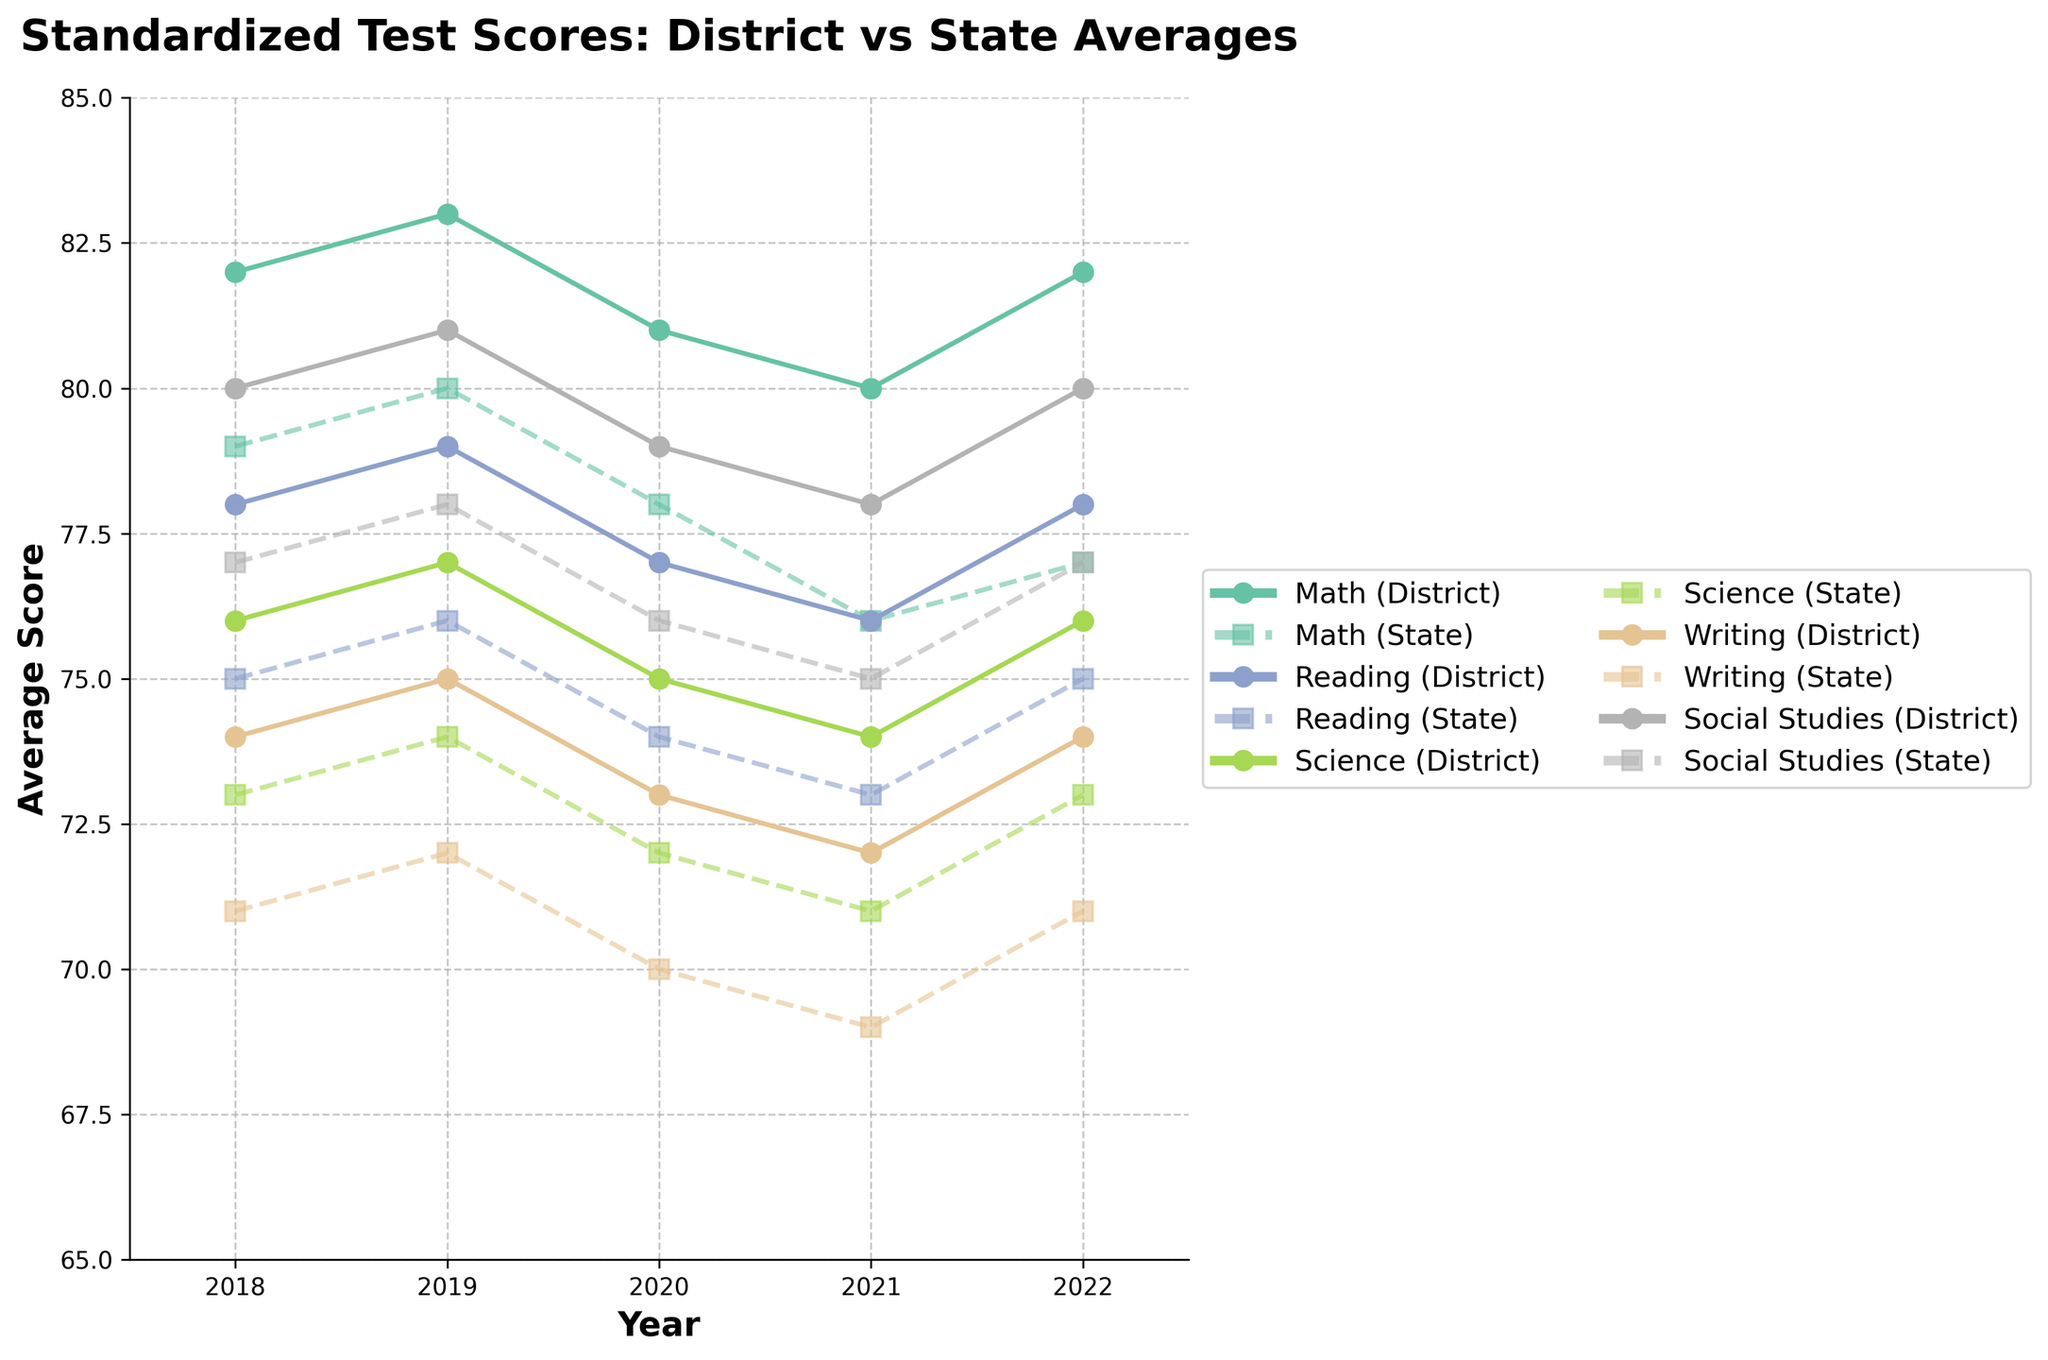What is the difference in Math scores between the district and the state in 2022? In the year 2022, the district average for Math is 82 while the state average is 77. The difference can be calculated by subtracting the state average from the district average: 82 - 77 = 5.
Answer: 5 Which subject shows the smallest difference between district and state averages in 2020? From the figure, observe the difference between district and state averages in 2020 for all subjects. The differences are: Math (81-78=3), Reading (77-74=3), Science (75-72=3), Writing (73-70=3), Social Studies (79-76=3). All subjects show the same smallest difference of 3 points.
Answer: All subjects During which year did the district average for Social Studies drop the most compared to the previous year? By examining the Social Studies district averages across the years: 2018 (80), 2019 (81), 2020 (79), 2021 (78), 2022 (80), the biggest drop occurred between 2019 and 2020, where the score dropped from 81 to 79, a drop of 2 points.
Answer: 2020 How does the trend in district average scores for Reading compare to the state average over the 5-year period? Over the 5-year period, the district and state average scores for Reading show a similar overall trend. Both see a slight decline from 2018 to 2021 and then an increase in 2022. Specifically, district scores go from 78 in 2018 to 78 in 2022, and state scores go from 75 in 2018 to 75 in 2022, reflecting stability in both.
Answer: Similar trend By how much did the district average for Writing change from 2018 to 2022? The Writing district average in 2018 was 74 and in 2022 it was 74 as well. The change from 2018 to 2022 is calculated as 74 - 74, which is 0, indicating no change over this period.
Answer: 0 In which year was the largest difference observed between district and state averages in Science? By comparing the difference each year for Science: 2018 (76-73=3), 2019 (77-74=3), 2020 (75-72=3), 2021 (74-71=3), 2022 (76-73=3), the largest difference of 3 points was consistent throughout all the years.
Answer: Every year What visual attribute changes significantly between subjects in the line chart? One of the most noticeable visual changes is the color used for plotting each subject, ensuring clear differentiation between subjects across the years.
Answer: Color Which year do Math district and state averages show the smallest gap? By checking the Math scores each year: 2018 (82-79=3), 2019 (83-80=3), 2020 (81-78=3), 2021 (80-76=4), 2022 (82-77=5), the smallest gap of 3 points is observed in 2018, 2019, and 2020.
Answer: 2018, 2019, 2020 In which year did the district average for Reading have its lowest value, and what was the score? Checking the Reading district averages over the years: 2018 (78), 2019 (79), 2020 (77), 2021 (76), 2022 (78), the lowest score was in 2021 with a value of 76.
Answer: 2021, 76 